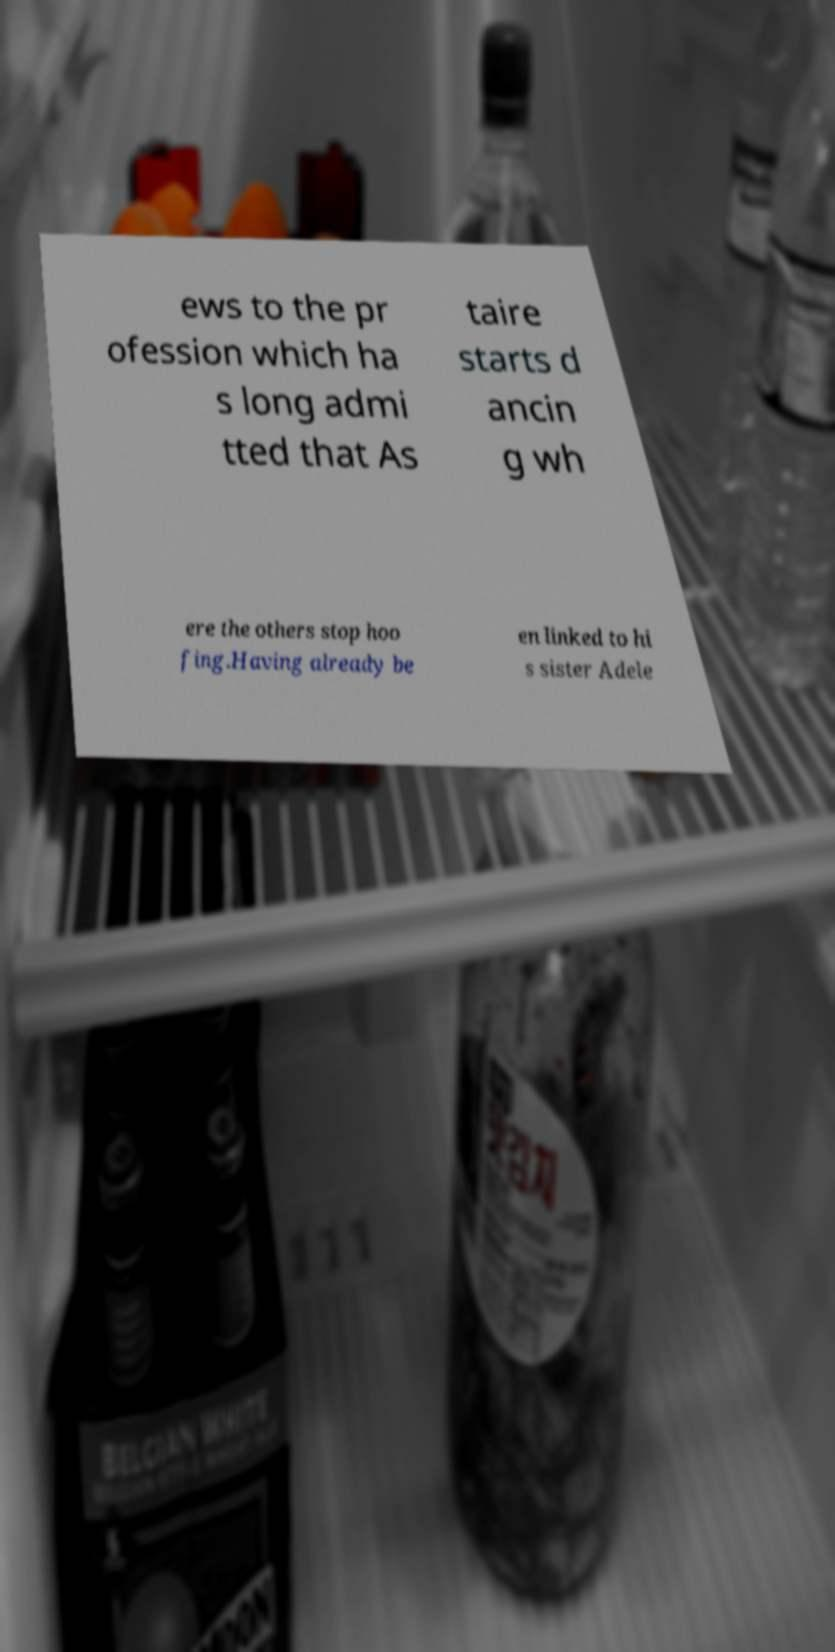Can you read and provide the text displayed in the image?This photo seems to have some interesting text. Can you extract and type it out for me? ews to the pr ofession which ha s long admi tted that As taire starts d ancin g wh ere the others stop hoo fing.Having already be en linked to hi s sister Adele 